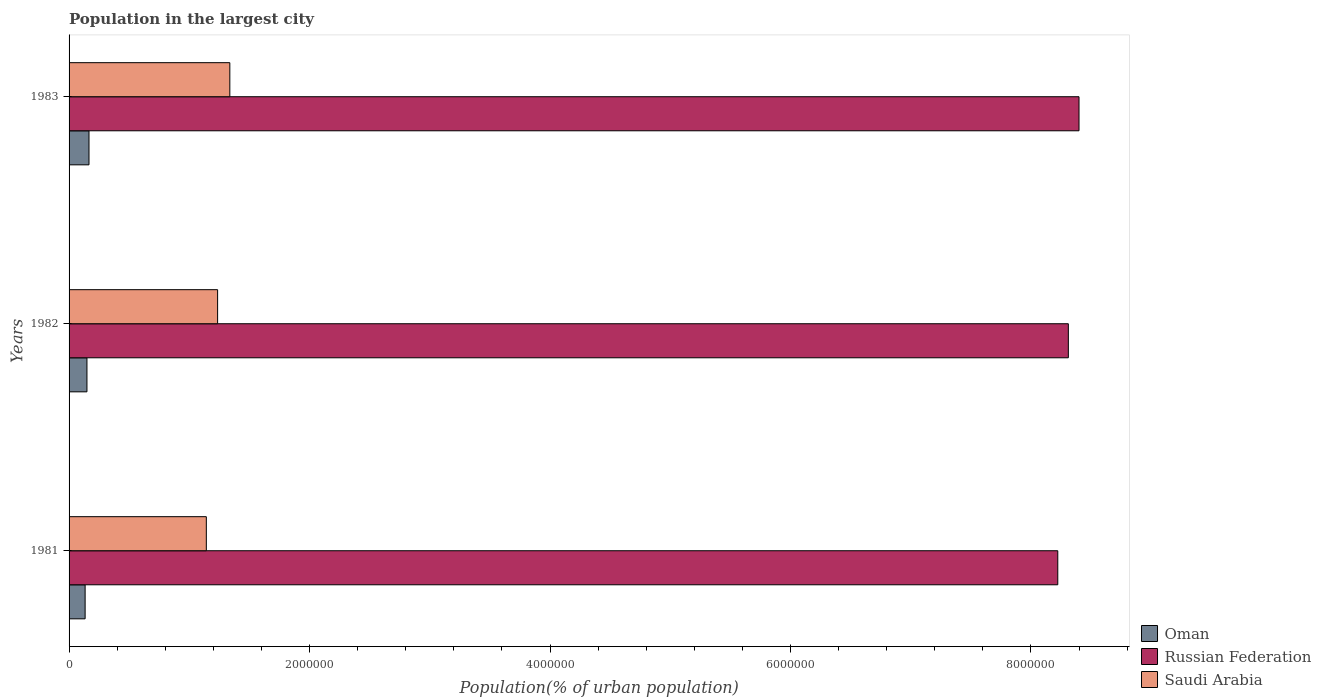Are the number of bars on each tick of the Y-axis equal?
Ensure brevity in your answer.  Yes. How many bars are there on the 2nd tick from the top?
Give a very brief answer. 3. How many bars are there on the 2nd tick from the bottom?
Give a very brief answer. 3. What is the label of the 1st group of bars from the top?
Make the answer very short. 1983. What is the population in the largest city in Oman in 1983?
Ensure brevity in your answer.  1.66e+05. Across all years, what is the maximum population in the largest city in Saudi Arabia?
Your answer should be compact. 1.34e+06. Across all years, what is the minimum population in the largest city in Saudi Arabia?
Provide a succinct answer. 1.14e+06. What is the total population in the largest city in Saudi Arabia in the graph?
Provide a succinct answer. 3.71e+06. What is the difference between the population in the largest city in Russian Federation in 1982 and that in 1983?
Make the answer very short. -8.88e+04. What is the difference between the population in the largest city in Oman in 1983 and the population in the largest city in Russian Federation in 1982?
Offer a very short reply. -8.15e+06. What is the average population in the largest city in Russian Federation per year?
Provide a succinct answer. 8.31e+06. In the year 1981, what is the difference between the population in the largest city in Oman and population in the largest city in Saudi Arabia?
Provide a short and direct response. -1.01e+06. What is the ratio of the population in the largest city in Russian Federation in 1981 to that in 1982?
Your answer should be compact. 0.99. Is the difference between the population in the largest city in Oman in 1981 and 1982 greater than the difference between the population in the largest city in Saudi Arabia in 1981 and 1982?
Offer a terse response. Yes. What is the difference between the highest and the second highest population in the largest city in Russian Federation?
Give a very brief answer. 8.88e+04. What is the difference between the highest and the lowest population in the largest city in Russian Federation?
Make the answer very short. 1.77e+05. In how many years, is the population in the largest city in Saudi Arabia greater than the average population in the largest city in Saudi Arabia taken over all years?
Keep it short and to the point. 1. What does the 1st bar from the top in 1983 represents?
Provide a short and direct response. Saudi Arabia. What does the 1st bar from the bottom in 1981 represents?
Offer a terse response. Oman. Is it the case that in every year, the sum of the population in the largest city in Saudi Arabia and population in the largest city in Russian Federation is greater than the population in the largest city in Oman?
Keep it short and to the point. Yes. How many bars are there?
Your answer should be very brief. 9. How many years are there in the graph?
Your answer should be compact. 3. What is the difference between two consecutive major ticks on the X-axis?
Ensure brevity in your answer.  2.00e+06. Are the values on the major ticks of X-axis written in scientific E-notation?
Give a very brief answer. No. Does the graph contain grids?
Offer a very short reply. No. How many legend labels are there?
Offer a terse response. 3. What is the title of the graph?
Ensure brevity in your answer.  Population in the largest city. What is the label or title of the X-axis?
Keep it short and to the point. Population(% of urban population). What is the label or title of the Y-axis?
Offer a terse response. Years. What is the Population(% of urban population) of Oman in 1981?
Your answer should be compact. 1.33e+05. What is the Population(% of urban population) of Russian Federation in 1981?
Your answer should be compact. 8.22e+06. What is the Population(% of urban population) of Saudi Arabia in 1981?
Make the answer very short. 1.14e+06. What is the Population(% of urban population) in Oman in 1982?
Provide a succinct answer. 1.49e+05. What is the Population(% of urban population) in Russian Federation in 1982?
Make the answer very short. 8.31e+06. What is the Population(% of urban population) of Saudi Arabia in 1982?
Make the answer very short. 1.24e+06. What is the Population(% of urban population) of Oman in 1983?
Keep it short and to the point. 1.66e+05. What is the Population(% of urban population) in Russian Federation in 1983?
Provide a short and direct response. 8.40e+06. What is the Population(% of urban population) of Saudi Arabia in 1983?
Give a very brief answer. 1.34e+06. Across all years, what is the maximum Population(% of urban population) of Oman?
Keep it short and to the point. 1.66e+05. Across all years, what is the maximum Population(% of urban population) in Russian Federation?
Make the answer very short. 8.40e+06. Across all years, what is the maximum Population(% of urban population) in Saudi Arabia?
Your answer should be very brief. 1.34e+06. Across all years, what is the minimum Population(% of urban population) in Oman?
Your response must be concise. 1.33e+05. Across all years, what is the minimum Population(% of urban population) in Russian Federation?
Ensure brevity in your answer.  8.22e+06. Across all years, what is the minimum Population(% of urban population) of Saudi Arabia?
Provide a short and direct response. 1.14e+06. What is the total Population(% of urban population) in Oman in the graph?
Your answer should be very brief. 4.48e+05. What is the total Population(% of urban population) in Russian Federation in the graph?
Your answer should be very brief. 2.49e+07. What is the total Population(% of urban population) of Saudi Arabia in the graph?
Offer a terse response. 3.71e+06. What is the difference between the Population(% of urban population) in Oman in 1981 and that in 1982?
Keep it short and to the point. -1.52e+04. What is the difference between the Population(% of urban population) of Russian Federation in 1981 and that in 1982?
Keep it short and to the point. -8.78e+04. What is the difference between the Population(% of urban population) of Saudi Arabia in 1981 and that in 1982?
Keep it short and to the point. -9.39e+04. What is the difference between the Population(% of urban population) of Oman in 1981 and that in 1983?
Provide a short and direct response. -3.22e+04. What is the difference between the Population(% of urban population) in Russian Federation in 1981 and that in 1983?
Offer a very short reply. -1.77e+05. What is the difference between the Population(% of urban population) of Saudi Arabia in 1981 and that in 1983?
Give a very brief answer. -1.96e+05. What is the difference between the Population(% of urban population) of Oman in 1982 and that in 1983?
Keep it short and to the point. -1.70e+04. What is the difference between the Population(% of urban population) of Russian Federation in 1982 and that in 1983?
Make the answer very short. -8.88e+04. What is the difference between the Population(% of urban population) of Saudi Arabia in 1982 and that in 1983?
Give a very brief answer. -1.02e+05. What is the difference between the Population(% of urban population) in Oman in 1981 and the Population(% of urban population) in Russian Federation in 1982?
Offer a terse response. -8.18e+06. What is the difference between the Population(% of urban population) in Oman in 1981 and the Population(% of urban population) in Saudi Arabia in 1982?
Provide a short and direct response. -1.10e+06. What is the difference between the Population(% of urban population) of Russian Federation in 1981 and the Population(% of urban population) of Saudi Arabia in 1982?
Offer a very short reply. 6.99e+06. What is the difference between the Population(% of urban population) in Oman in 1981 and the Population(% of urban population) in Russian Federation in 1983?
Your response must be concise. -8.27e+06. What is the difference between the Population(% of urban population) of Oman in 1981 and the Population(% of urban population) of Saudi Arabia in 1983?
Your answer should be compact. -1.20e+06. What is the difference between the Population(% of urban population) of Russian Federation in 1981 and the Population(% of urban population) of Saudi Arabia in 1983?
Offer a very short reply. 6.89e+06. What is the difference between the Population(% of urban population) of Oman in 1982 and the Population(% of urban population) of Russian Federation in 1983?
Offer a terse response. -8.25e+06. What is the difference between the Population(% of urban population) in Oman in 1982 and the Population(% of urban population) in Saudi Arabia in 1983?
Offer a terse response. -1.19e+06. What is the difference between the Population(% of urban population) of Russian Federation in 1982 and the Population(% of urban population) of Saudi Arabia in 1983?
Provide a short and direct response. 6.97e+06. What is the average Population(% of urban population) in Oman per year?
Make the answer very short. 1.49e+05. What is the average Population(% of urban population) in Russian Federation per year?
Ensure brevity in your answer.  8.31e+06. What is the average Population(% of urban population) of Saudi Arabia per year?
Your answer should be compact. 1.24e+06. In the year 1981, what is the difference between the Population(% of urban population) in Oman and Population(% of urban population) in Russian Federation?
Give a very brief answer. -8.09e+06. In the year 1981, what is the difference between the Population(% of urban population) of Oman and Population(% of urban population) of Saudi Arabia?
Provide a succinct answer. -1.01e+06. In the year 1981, what is the difference between the Population(% of urban population) of Russian Federation and Population(% of urban population) of Saudi Arabia?
Offer a very short reply. 7.08e+06. In the year 1982, what is the difference between the Population(% of urban population) of Oman and Population(% of urban population) of Russian Federation?
Give a very brief answer. -8.16e+06. In the year 1982, what is the difference between the Population(% of urban population) in Oman and Population(% of urban population) in Saudi Arabia?
Offer a terse response. -1.09e+06. In the year 1982, what is the difference between the Population(% of urban population) of Russian Federation and Population(% of urban population) of Saudi Arabia?
Give a very brief answer. 7.08e+06. In the year 1983, what is the difference between the Population(% of urban population) of Oman and Population(% of urban population) of Russian Federation?
Keep it short and to the point. -8.23e+06. In the year 1983, what is the difference between the Population(% of urban population) of Oman and Population(% of urban population) of Saudi Arabia?
Provide a succinct answer. -1.17e+06. In the year 1983, what is the difference between the Population(% of urban population) in Russian Federation and Population(% of urban population) in Saudi Arabia?
Provide a short and direct response. 7.06e+06. What is the ratio of the Population(% of urban population) in Oman in 1981 to that in 1982?
Provide a short and direct response. 0.9. What is the ratio of the Population(% of urban population) in Saudi Arabia in 1981 to that in 1982?
Your answer should be very brief. 0.92. What is the ratio of the Population(% of urban population) in Oman in 1981 to that in 1983?
Offer a very short reply. 0.81. What is the ratio of the Population(% of urban population) in Saudi Arabia in 1981 to that in 1983?
Keep it short and to the point. 0.85. What is the ratio of the Population(% of urban population) in Oman in 1982 to that in 1983?
Offer a terse response. 0.9. What is the ratio of the Population(% of urban population) of Russian Federation in 1982 to that in 1983?
Offer a very short reply. 0.99. What is the ratio of the Population(% of urban population) in Saudi Arabia in 1982 to that in 1983?
Offer a very short reply. 0.92. What is the difference between the highest and the second highest Population(% of urban population) in Oman?
Your answer should be very brief. 1.70e+04. What is the difference between the highest and the second highest Population(% of urban population) in Russian Federation?
Keep it short and to the point. 8.88e+04. What is the difference between the highest and the second highest Population(% of urban population) of Saudi Arabia?
Ensure brevity in your answer.  1.02e+05. What is the difference between the highest and the lowest Population(% of urban population) in Oman?
Keep it short and to the point. 3.22e+04. What is the difference between the highest and the lowest Population(% of urban population) in Russian Federation?
Provide a succinct answer. 1.77e+05. What is the difference between the highest and the lowest Population(% of urban population) of Saudi Arabia?
Ensure brevity in your answer.  1.96e+05. 